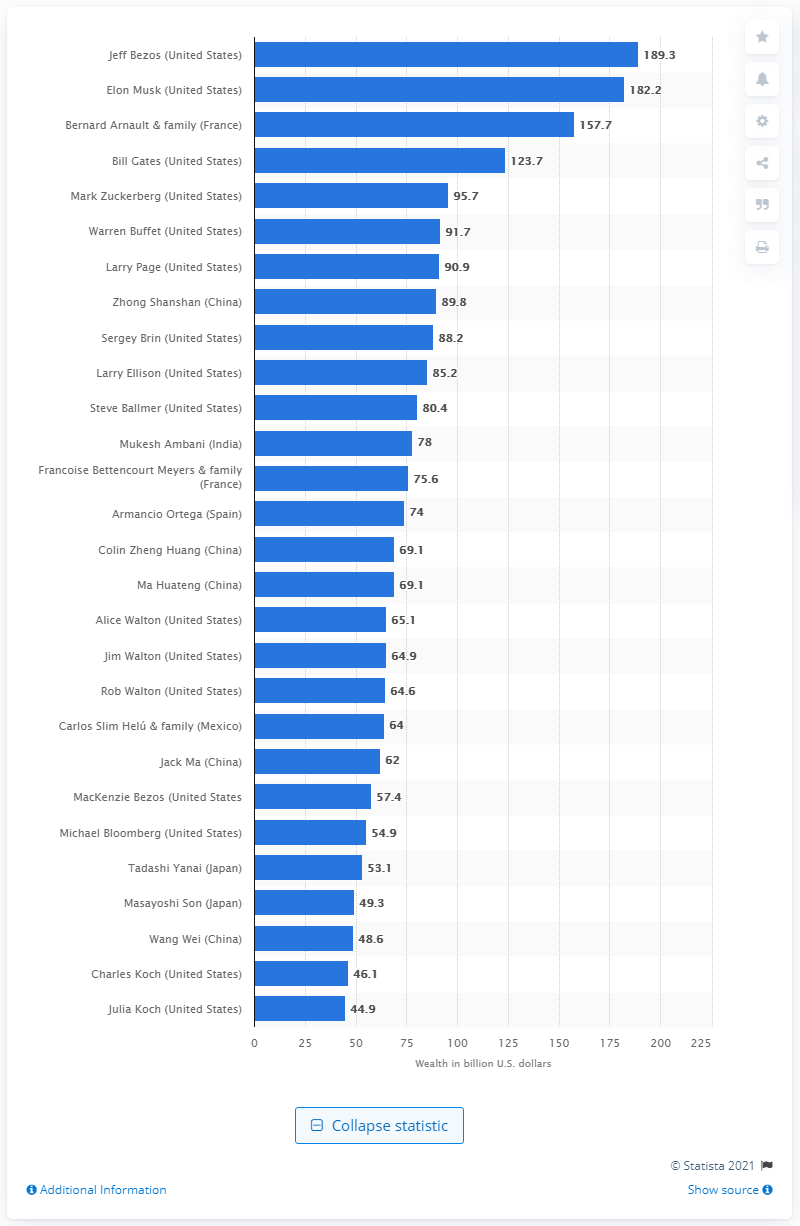Draw attention to some important aspects in this diagram. Elon Musk's net worth was 182.2 billion dollars at the time. As of February 2021, Jeff Bezos' net worth was approximately 189.3 billion US dollars. 